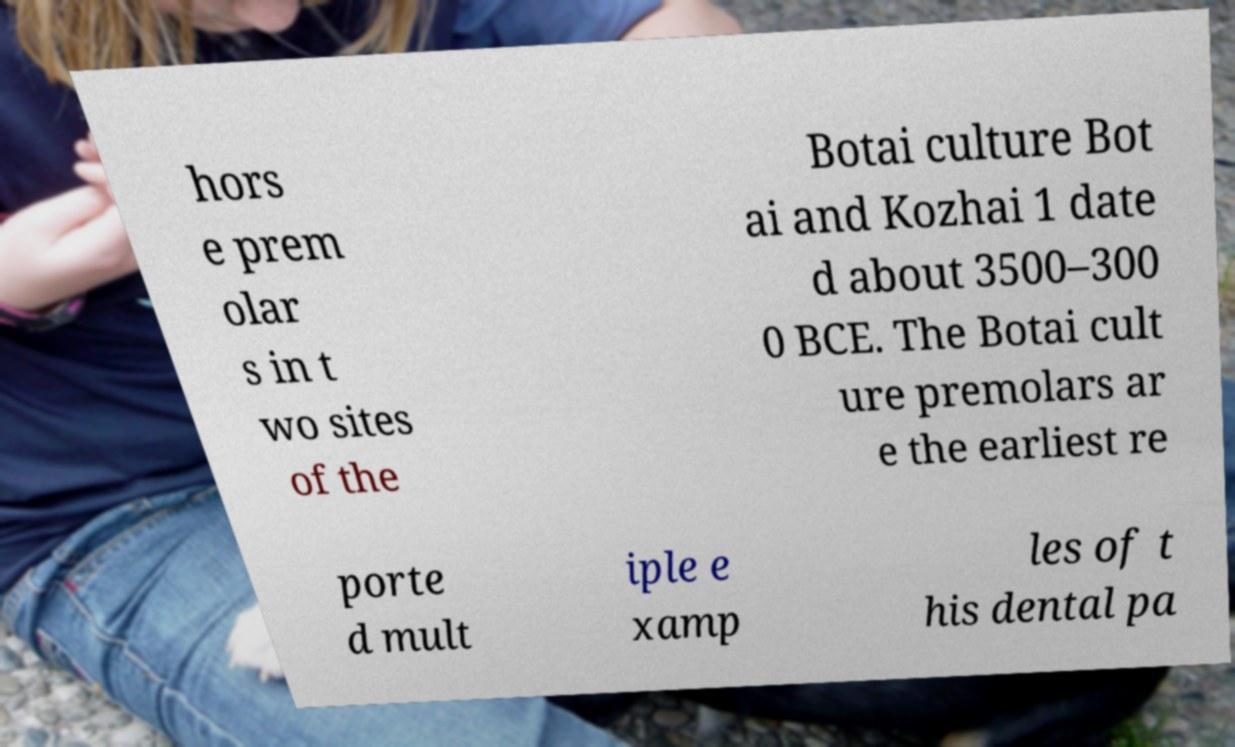I need the written content from this picture converted into text. Can you do that? hors e prem olar s in t wo sites of the Botai culture Bot ai and Kozhai 1 date d about 3500–300 0 BCE. The Botai cult ure premolars ar e the earliest re porte d mult iple e xamp les of t his dental pa 